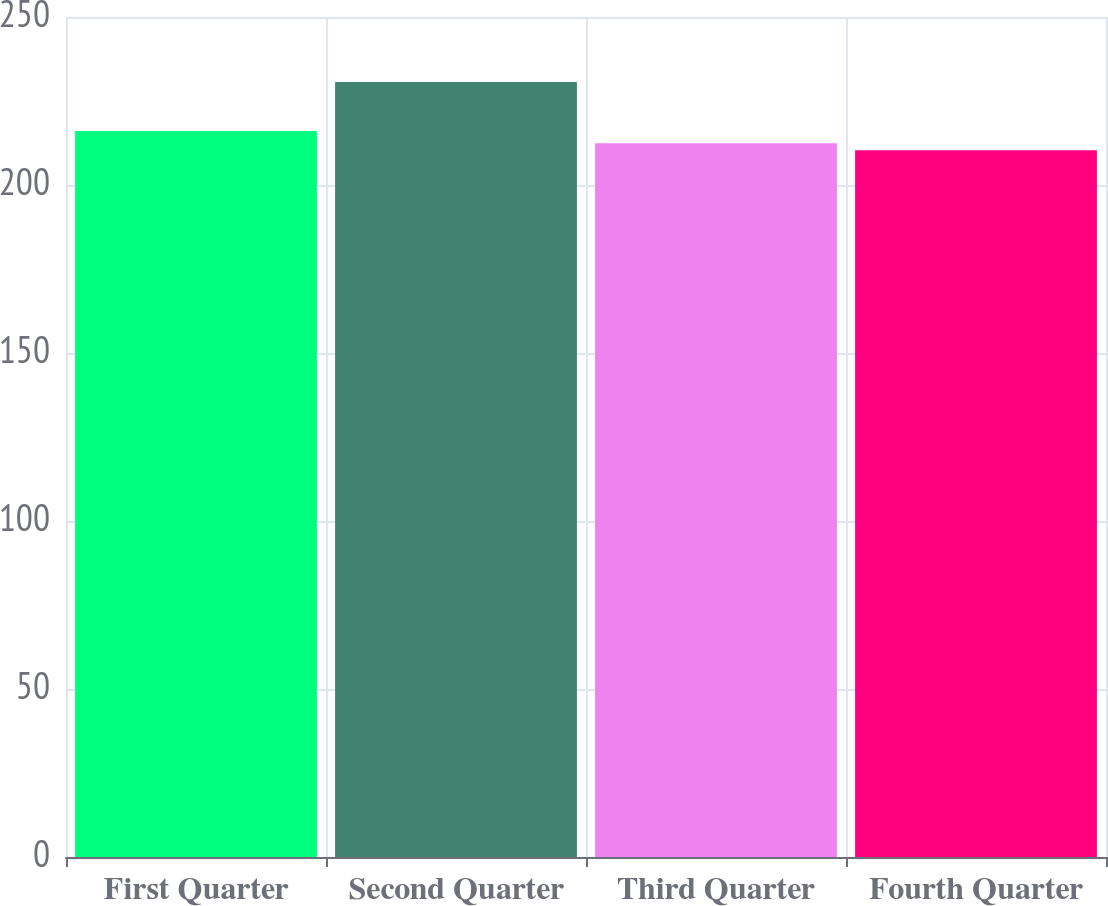<chart> <loc_0><loc_0><loc_500><loc_500><bar_chart><fcel>First Quarter<fcel>Second Quarter<fcel>Third Quarter<fcel>Fourth Quarter<nl><fcel>216.04<fcel>230.63<fcel>212.39<fcel>210.36<nl></chart> 